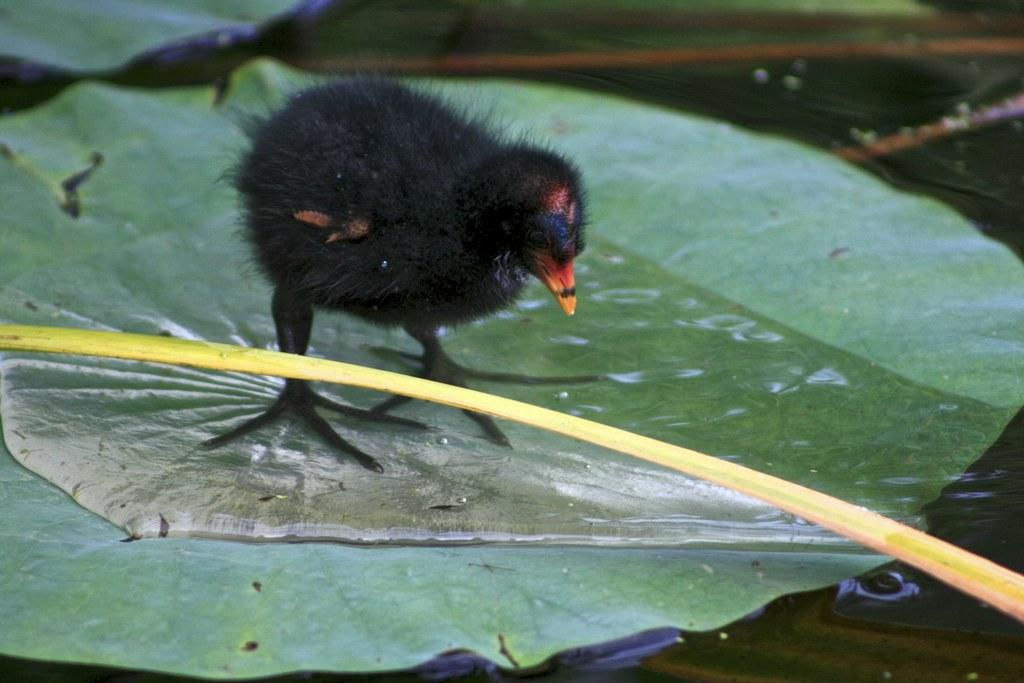What animal is present in the image? There is a chicken in the image. What is the chicken standing on? The chicken is standing on a leaf. What type of road can be seen in the image? There is no road present in the image; it features a chicken standing on a leaf. Can you describe the cemetery in the image? There is no cemetery present in the image; it features a chicken standing on a leaf. 